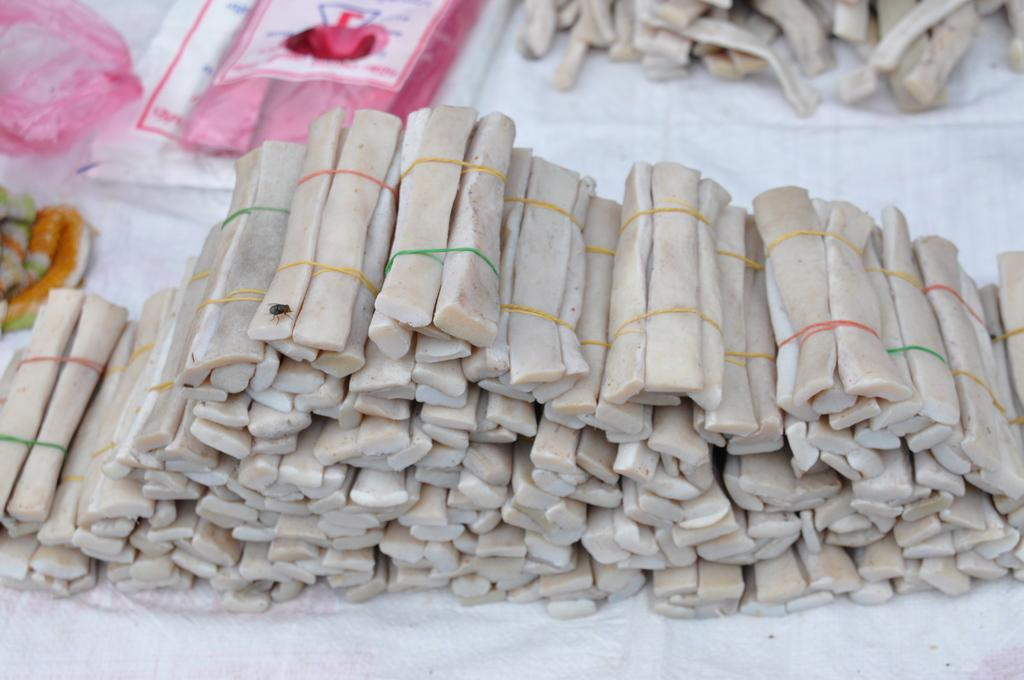What type of food can be seen on the table in the foreground? There are bundles of Chinese food on the table in the foreground. What else is visible in the background of the image? In the background, there is additional food and covers or tablecloths. What type of yarn is used to decorate the cushions in the image? There are no cushions or yarn present in the image. 